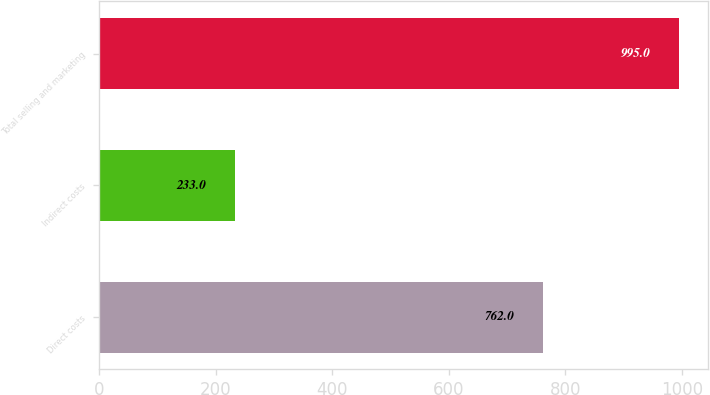<chart> <loc_0><loc_0><loc_500><loc_500><bar_chart><fcel>Direct costs<fcel>Indirect costs<fcel>Total selling and marketing<nl><fcel>762<fcel>233<fcel>995<nl></chart> 